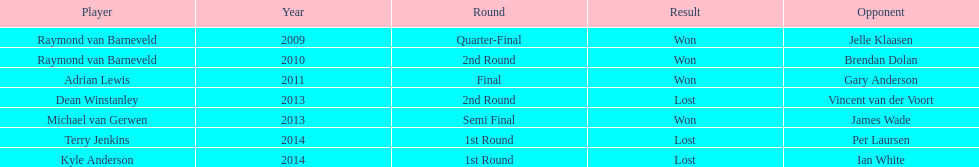Who was the last to win against his opponent? Michael van Gerwen. 